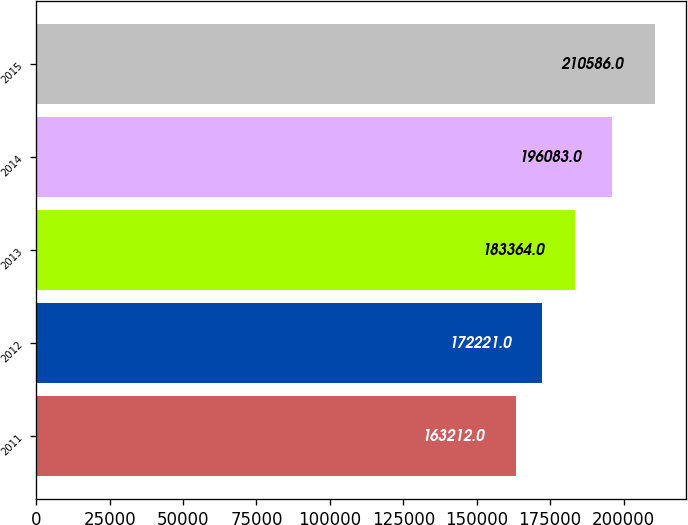Convert chart to OTSL. <chart><loc_0><loc_0><loc_500><loc_500><bar_chart><fcel>2011<fcel>2012<fcel>2013<fcel>2014<fcel>2015<nl><fcel>163212<fcel>172221<fcel>183364<fcel>196083<fcel>210586<nl></chart> 